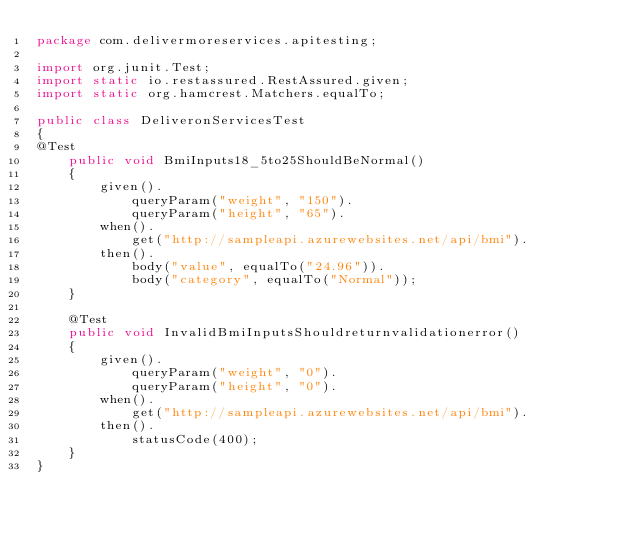Convert code to text. <code><loc_0><loc_0><loc_500><loc_500><_Java_>package com.delivermoreservices.apitesting;

import org.junit.Test;
import static io.restassured.RestAssured.given;
import static org.hamcrest.Matchers.equalTo;

public class DeliveronServicesTest
{
@Test
    public void BmiInputs18_5to25ShouldBeNormal()
    {
        given().
            queryParam("weight", "150").
            queryParam("height", "65").
        when().
            get("http://sampleapi.azurewebsites.net/api/bmi").
        then().    
            body("value", equalTo("24.96")).
            body("category", equalTo("Normal"));
    }

    @Test
    public void InvalidBmiInputsShouldreturnvalidationerror()
    {
        given().
            queryParam("weight", "0").
            queryParam("height", "0").
        when().
            get("http://sampleapi.azurewebsites.net/api/bmi").
        then().    
            statusCode(400);
    }
}</code> 